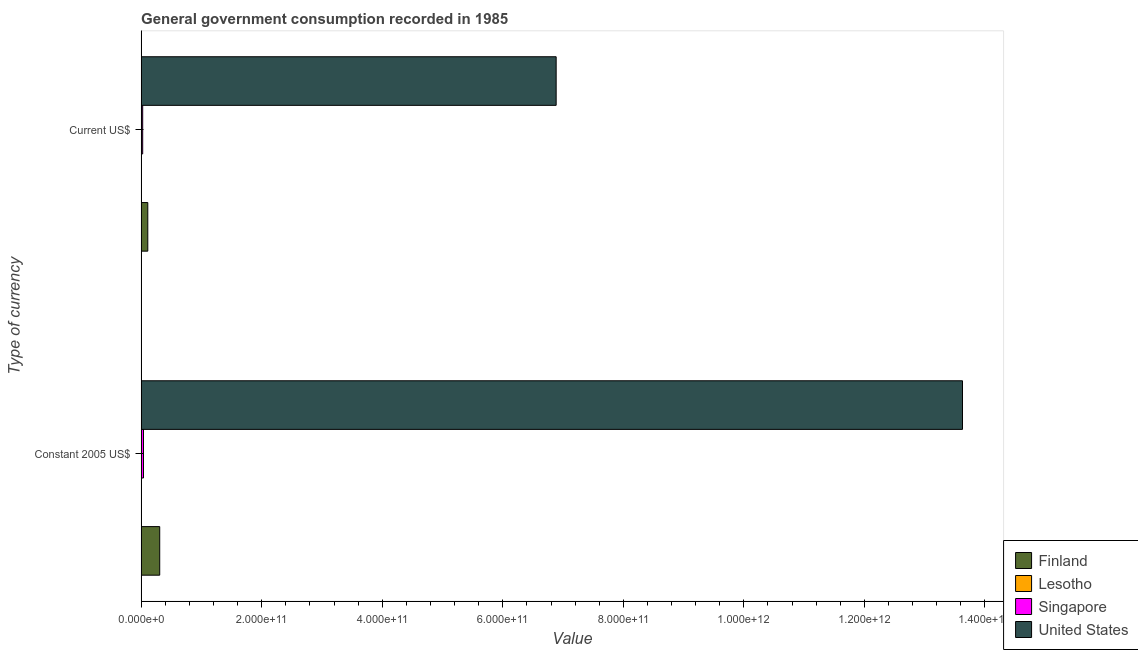How many different coloured bars are there?
Your answer should be very brief. 4. How many groups of bars are there?
Offer a very short reply. 2. Are the number of bars per tick equal to the number of legend labels?
Your answer should be compact. Yes. How many bars are there on the 1st tick from the top?
Your answer should be very brief. 4. What is the label of the 1st group of bars from the top?
Your answer should be very brief. Current US$. What is the value consumed in current us$ in Lesotho?
Ensure brevity in your answer.  4.23e+07. Across all countries, what is the maximum value consumed in current us$?
Make the answer very short. 6.89e+11. Across all countries, what is the minimum value consumed in current us$?
Your answer should be compact. 4.23e+07. In which country was the value consumed in constant 2005 us$ minimum?
Ensure brevity in your answer.  Lesotho. What is the total value consumed in constant 2005 us$ in the graph?
Offer a very short reply. 1.40e+12. What is the difference between the value consumed in current us$ in United States and that in Lesotho?
Ensure brevity in your answer.  6.89e+11. What is the difference between the value consumed in current us$ in Finland and the value consumed in constant 2005 us$ in Singapore?
Keep it short and to the point. 7.13e+09. What is the average value consumed in constant 2005 us$ per country?
Provide a succinct answer. 3.49e+11. What is the difference between the value consumed in constant 2005 us$ and value consumed in current us$ in United States?
Provide a short and direct response. 6.74e+11. In how many countries, is the value consumed in current us$ greater than 160000000000 ?
Provide a succinct answer. 1. What is the ratio of the value consumed in constant 2005 us$ in Lesotho to that in Finland?
Offer a terse response. 0. Is the value consumed in constant 2005 us$ in Lesotho less than that in Singapore?
Provide a short and direct response. Yes. What does the 2nd bar from the top in Current US$ represents?
Provide a succinct answer. Singapore. What does the 2nd bar from the bottom in Constant 2005 US$ represents?
Provide a short and direct response. Lesotho. How many bars are there?
Your response must be concise. 8. Are all the bars in the graph horizontal?
Make the answer very short. Yes. What is the difference between two consecutive major ticks on the X-axis?
Offer a terse response. 2.00e+11. Does the graph contain any zero values?
Offer a terse response. No. Does the graph contain grids?
Keep it short and to the point. No. Where does the legend appear in the graph?
Offer a very short reply. Bottom right. How many legend labels are there?
Keep it short and to the point. 4. How are the legend labels stacked?
Offer a terse response. Vertical. What is the title of the graph?
Offer a terse response. General government consumption recorded in 1985. Does "Panama" appear as one of the legend labels in the graph?
Keep it short and to the point. No. What is the label or title of the X-axis?
Your answer should be very brief. Value. What is the label or title of the Y-axis?
Your response must be concise. Type of currency. What is the Value in Finland in Constant 2005 US$?
Ensure brevity in your answer.  3.08e+1. What is the Value of Lesotho in Constant 2005 US$?
Make the answer very short. 5.58e+07. What is the Value of Singapore in Constant 2005 US$?
Offer a terse response. 3.90e+09. What is the Value in United States in Constant 2005 US$?
Give a very brief answer. 1.36e+12. What is the Value of Finland in Current US$?
Your response must be concise. 1.10e+1. What is the Value of Lesotho in Current US$?
Offer a terse response. 4.23e+07. What is the Value of Singapore in Current US$?
Offer a terse response. 2.57e+09. What is the Value of United States in Current US$?
Offer a very short reply. 6.89e+11. Across all Type of currency, what is the maximum Value of Finland?
Make the answer very short. 3.08e+1. Across all Type of currency, what is the maximum Value in Lesotho?
Ensure brevity in your answer.  5.58e+07. Across all Type of currency, what is the maximum Value in Singapore?
Provide a succinct answer. 3.90e+09. Across all Type of currency, what is the maximum Value of United States?
Make the answer very short. 1.36e+12. Across all Type of currency, what is the minimum Value of Finland?
Provide a short and direct response. 1.10e+1. Across all Type of currency, what is the minimum Value of Lesotho?
Give a very brief answer. 4.23e+07. Across all Type of currency, what is the minimum Value of Singapore?
Offer a very short reply. 2.57e+09. Across all Type of currency, what is the minimum Value of United States?
Provide a short and direct response. 6.89e+11. What is the total Value in Finland in the graph?
Give a very brief answer. 4.18e+1. What is the total Value in Lesotho in the graph?
Give a very brief answer. 9.81e+07. What is the total Value in Singapore in the graph?
Your answer should be compact. 6.46e+09. What is the total Value in United States in the graph?
Provide a succinct answer. 2.05e+12. What is the difference between the Value in Finland in Constant 2005 US$ and that in Current US$?
Provide a succinct answer. 1.98e+1. What is the difference between the Value of Lesotho in Constant 2005 US$ and that in Current US$?
Offer a terse response. 1.34e+07. What is the difference between the Value in Singapore in Constant 2005 US$ and that in Current US$?
Make the answer very short. 1.33e+09. What is the difference between the Value in United States in Constant 2005 US$ and that in Current US$?
Keep it short and to the point. 6.74e+11. What is the difference between the Value in Finland in Constant 2005 US$ and the Value in Lesotho in Current US$?
Offer a very short reply. 3.08e+1. What is the difference between the Value of Finland in Constant 2005 US$ and the Value of Singapore in Current US$?
Offer a terse response. 2.82e+1. What is the difference between the Value in Finland in Constant 2005 US$ and the Value in United States in Current US$?
Provide a succinct answer. -6.58e+11. What is the difference between the Value of Lesotho in Constant 2005 US$ and the Value of Singapore in Current US$?
Your response must be concise. -2.51e+09. What is the difference between the Value in Lesotho in Constant 2005 US$ and the Value in United States in Current US$?
Ensure brevity in your answer.  -6.89e+11. What is the difference between the Value in Singapore in Constant 2005 US$ and the Value in United States in Current US$?
Offer a very short reply. -6.85e+11. What is the average Value of Finland per Type of currency?
Provide a succinct answer. 2.09e+1. What is the average Value of Lesotho per Type of currency?
Your answer should be compact. 4.90e+07. What is the average Value of Singapore per Type of currency?
Offer a terse response. 3.23e+09. What is the average Value of United States per Type of currency?
Your answer should be very brief. 1.03e+12. What is the difference between the Value of Finland and Value of Lesotho in Constant 2005 US$?
Your answer should be very brief. 3.07e+1. What is the difference between the Value in Finland and Value in Singapore in Constant 2005 US$?
Your answer should be compact. 2.69e+1. What is the difference between the Value of Finland and Value of United States in Constant 2005 US$?
Keep it short and to the point. -1.33e+12. What is the difference between the Value in Lesotho and Value in Singapore in Constant 2005 US$?
Ensure brevity in your answer.  -3.84e+09. What is the difference between the Value in Lesotho and Value in United States in Constant 2005 US$?
Keep it short and to the point. -1.36e+12. What is the difference between the Value of Singapore and Value of United States in Constant 2005 US$?
Your answer should be compact. -1.36e+12. What is the difference between the Value in Finland and Value in Lesotho in Current US$?
Give a very brief answer. 1.10e+1. What is the difference between the Value of Finland and Value of Singapore in Current US$?
Keep it short and to the point. 8.46e+09. What is the difference between the Value in Finland and Value in United States in Current US$?
Make the answer very short. -6.78e+11. What is the difference between the Value in Lesotho and Value in Singapore in Current US$?
Provide a succinct answer. -2.52e+09. What is the difference between the Value of Lesotho and Value of United States in Current US$?
Make the answer very short. -6.89e+11. What is the difference between the Value in Singapore and Value in United States in Current US$?
Your response must be concise. -6.86e+11. What is the ratio of the Value of Finland in Constant 2005 US$ to that in Current US$?
Ensure brevity in your answer.  2.79. What is the ratio of the Value in Lesotho in Constant 2005 US$ to that in Current US$?
Offer a very short reply. 1.32. What is the ratio of the Value of Singapore in Constant 2005 US$ to that in Current US$?
Ensure brevity in your answer.  1.52. What is the ratio of the Value of United States in Constant 2005 US$ to that in Current US$?
Keep it short and to the point. 1.98. What is the difference between the highest and the second highest Value in Finland?
Offer a very short reply. 1.98e+1. What is the difference between the highest and the second highest Value of Lesotho?
Your response must be concise. 1.34e+07. What is the difference between the highest and the second highest Value of Singapore?
Give a very brief answer. 1.33e+09. What is the difference between the highest and the second highest Value in United States?
Offer a terse response. 6.74e+11. What is the difference between the highest and the lowest Value in Finland?
Your answer should be compact. 1.98e+1. What is the difference between the highest and the lowest Value of Lesotho?
Ensure brevity in your answer.  1.34e+07. What is the difference between the highest and the lowest Value in Singapore?
Offer a terse response. 1.33e+09. What is the difference between the highest and the lowest Value of United States?
Your answer should be compact. 6.74e+11. 